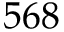<formula> <loc_0><loc_0><loc_500><loc_500>5 6 8</formula> 